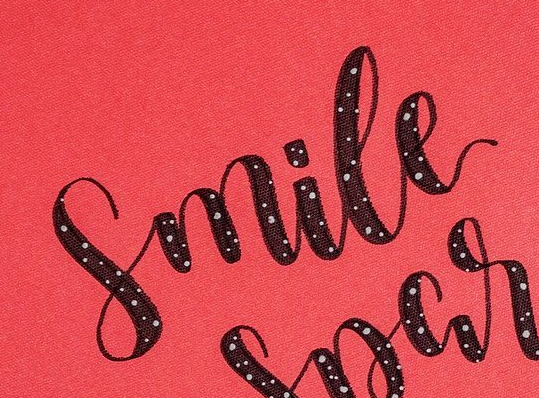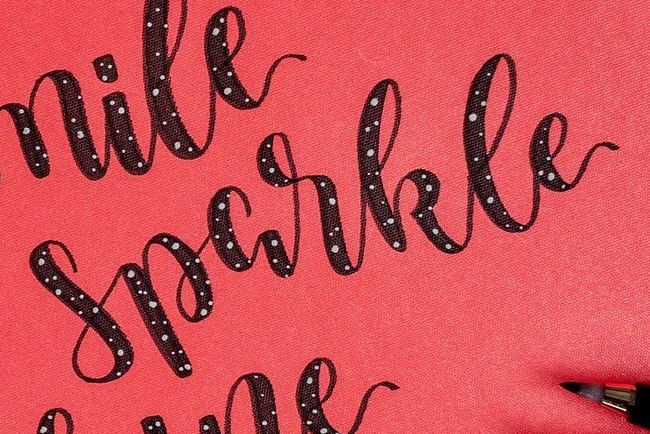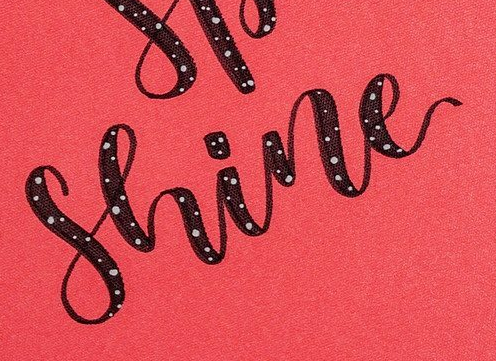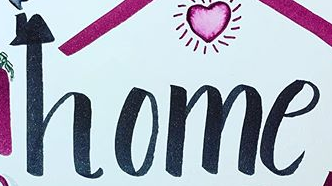What words are shown in these images in order, separated by a semicolon? Smile; Sparkle; Shine; home 